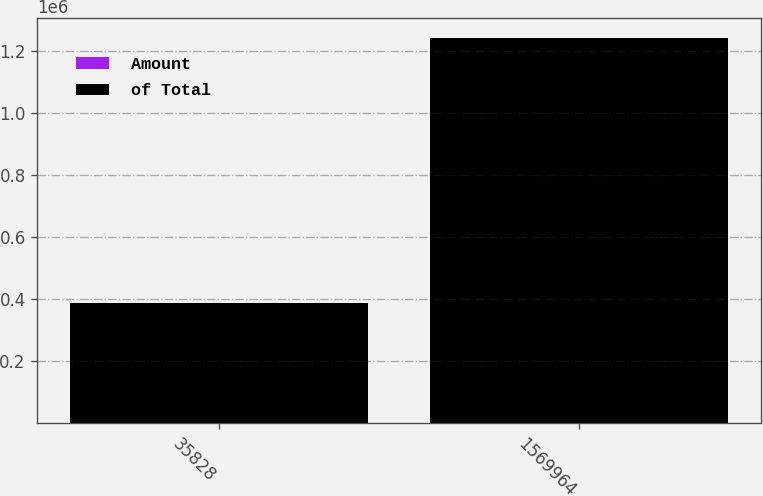Convert chart. <chart><loc_0><loc_0><loc_500><loc_500><stacked_bar_chart><ecel><fcel>35828<fcel>1569964<nl><fcel>Amount<fcel>2<fcel>100<nl><fcel>of Total<fcel>388410<fcel>1.24413e+06<nl></chart> 